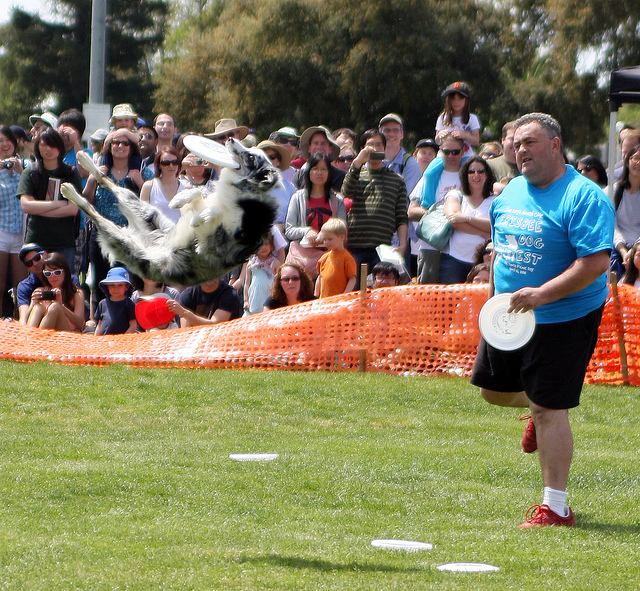Identify the text displayed in this image. DCG EST 